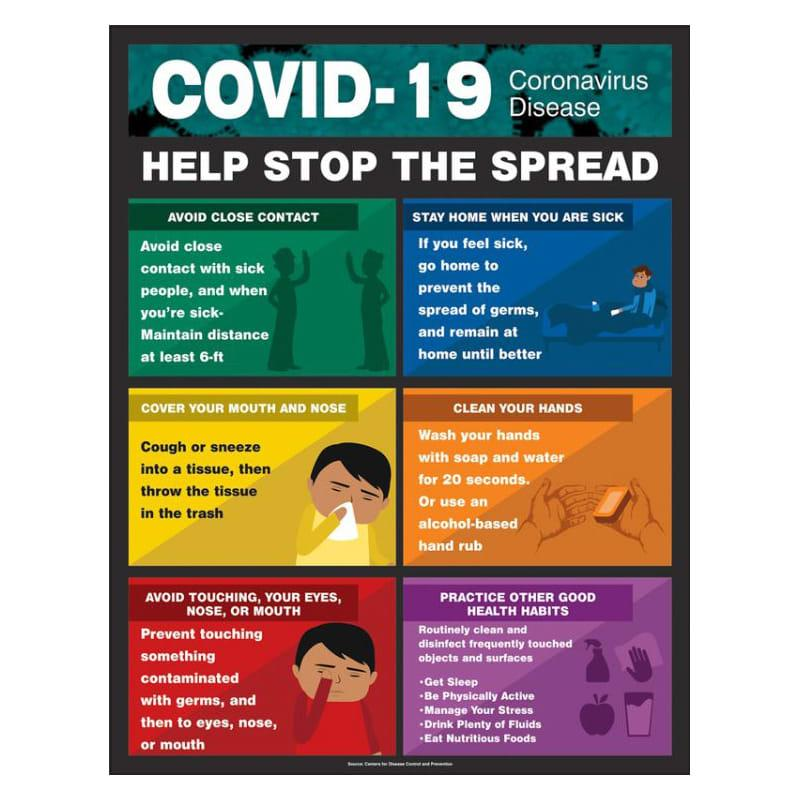List a handful of essential elements in this visual. It is important to clean your hands using an alcohol-based hand rub as an alternative to soap and water when soap and water are not readily available, as alcohol-based hand rubs are effective in killing germs and bacteria on your hands. The fifth health practice listed in the infographic is "Eat Nutritious Foods. The body parts that should be carefully avoided to prevent the spread of the COVID-19 virus are the eyes, nose, and mouth. Be Physically Active" is the second health practice listed in the infographic. It is appropriate to dispose of used paper handkerchiefs by throwing them in the trash. 